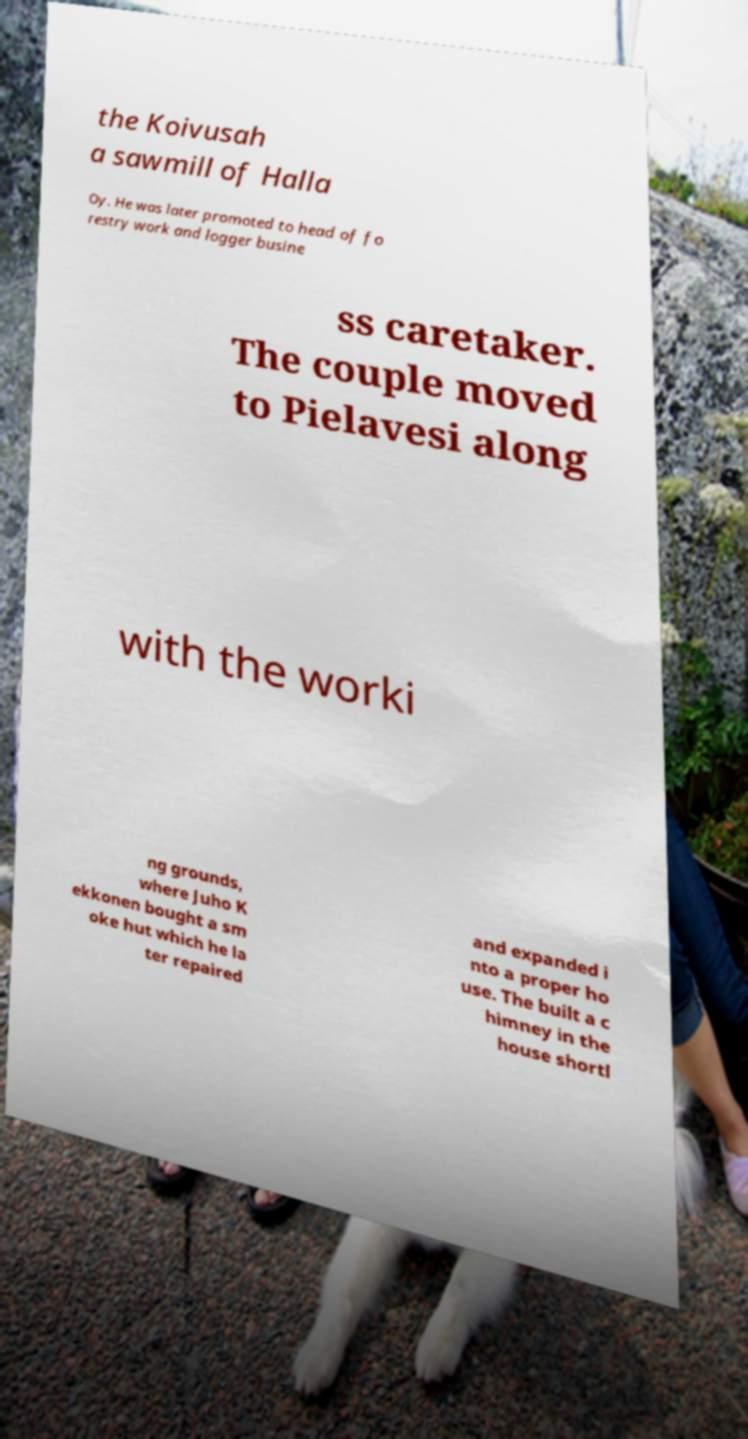Please read and relay the text visible in this image. What does it say? the Koivusah a sawmill of Halla Oy. He was later promoted to head of fo restry work and logger busine ss caretaker. The couple moved to Pielavesi along with the worki ng grounds, where Juho K ekkonen bought a sm oke hut which he la ter repaired and expanded i nto a proper ho use. The built a c himney in the house shortl 